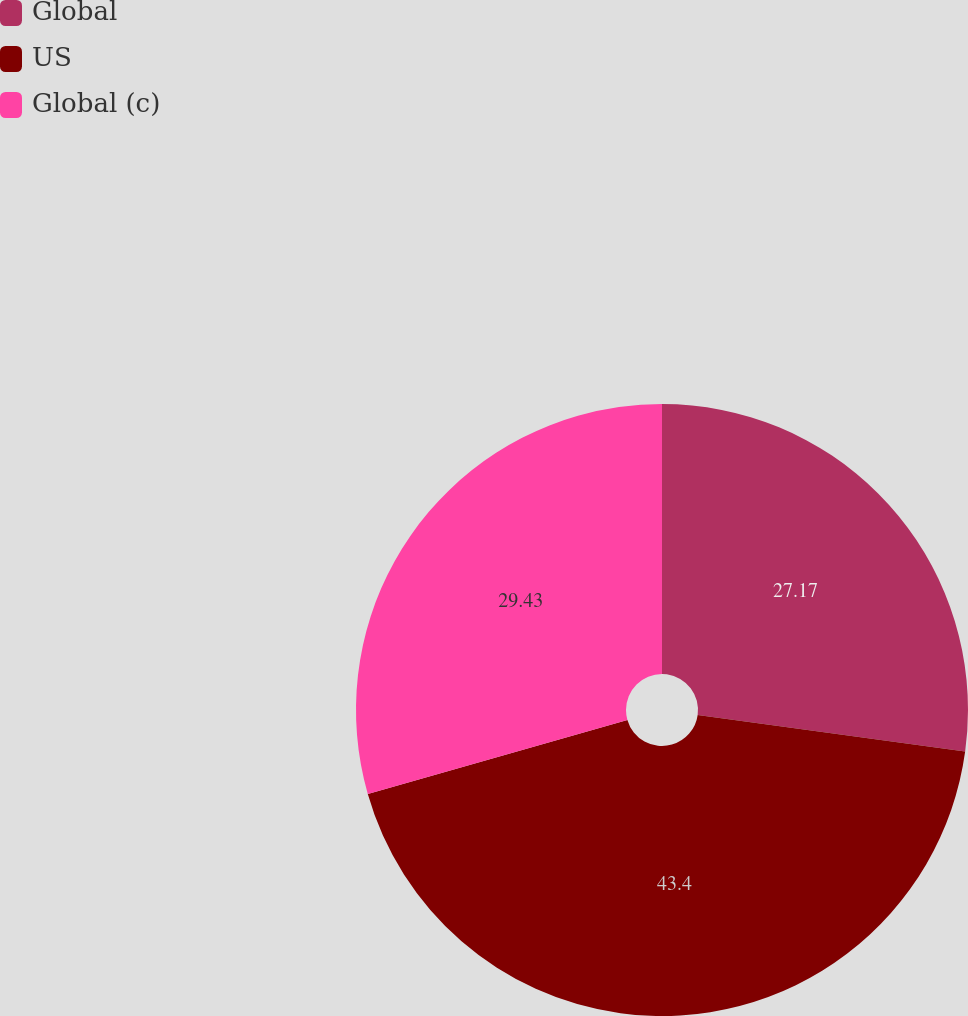Convert chart to OTSL. <chart><loc_0><loc_0><loc_500><loc_500><pie_chart><fcel>Global<fcel>US<fcel>Global (c)<nl><fcel>27.17%<fcel>43.4%<fcel>29.43%<nl></chart> 